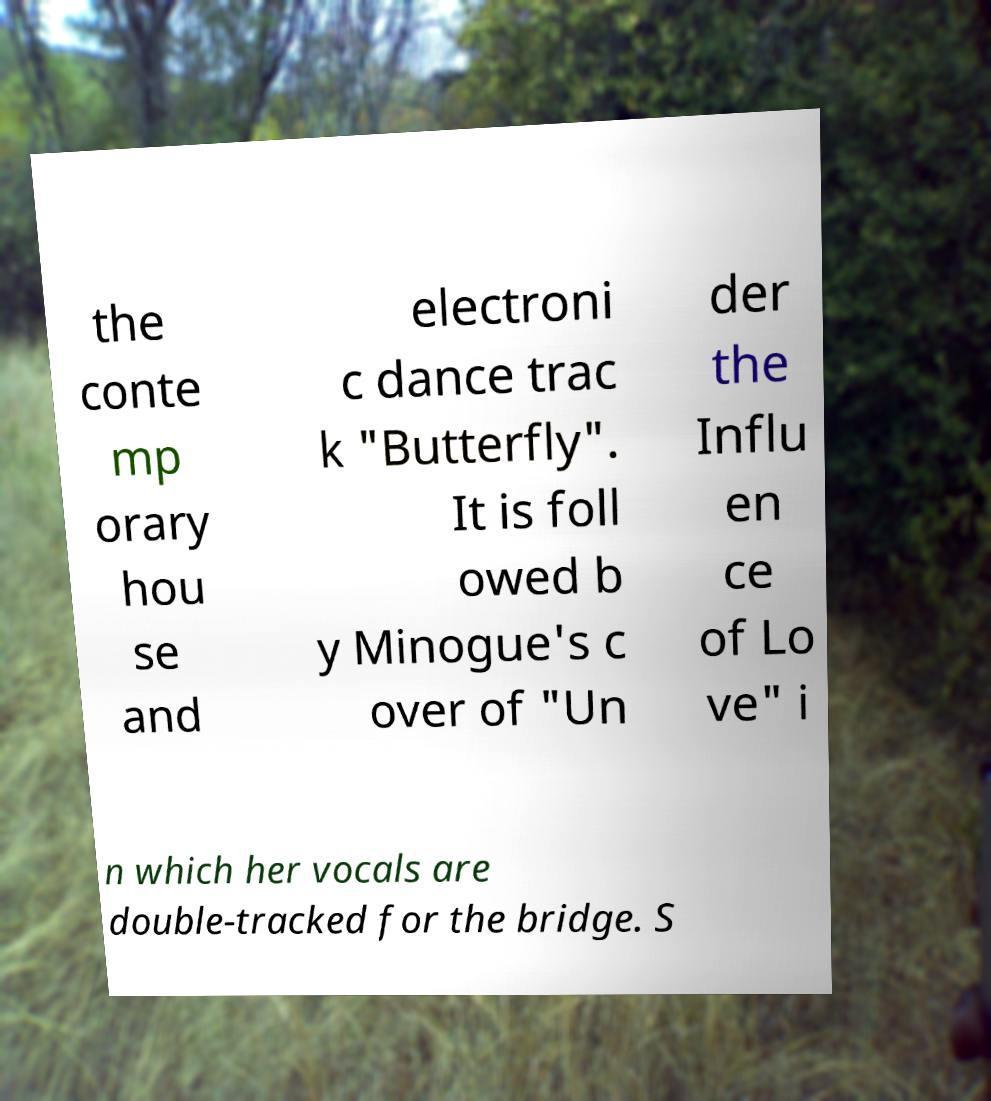What messages or text are displayed in this image? I need them in a readable, typed format. the conte mp orary hou se and electroni c dance trac k "Butterfly". It is foll owed b y Minogue's c over of "Un der the Influ en ce of Lo ve" i n which her vocals are double-tracked for the bridge. S 